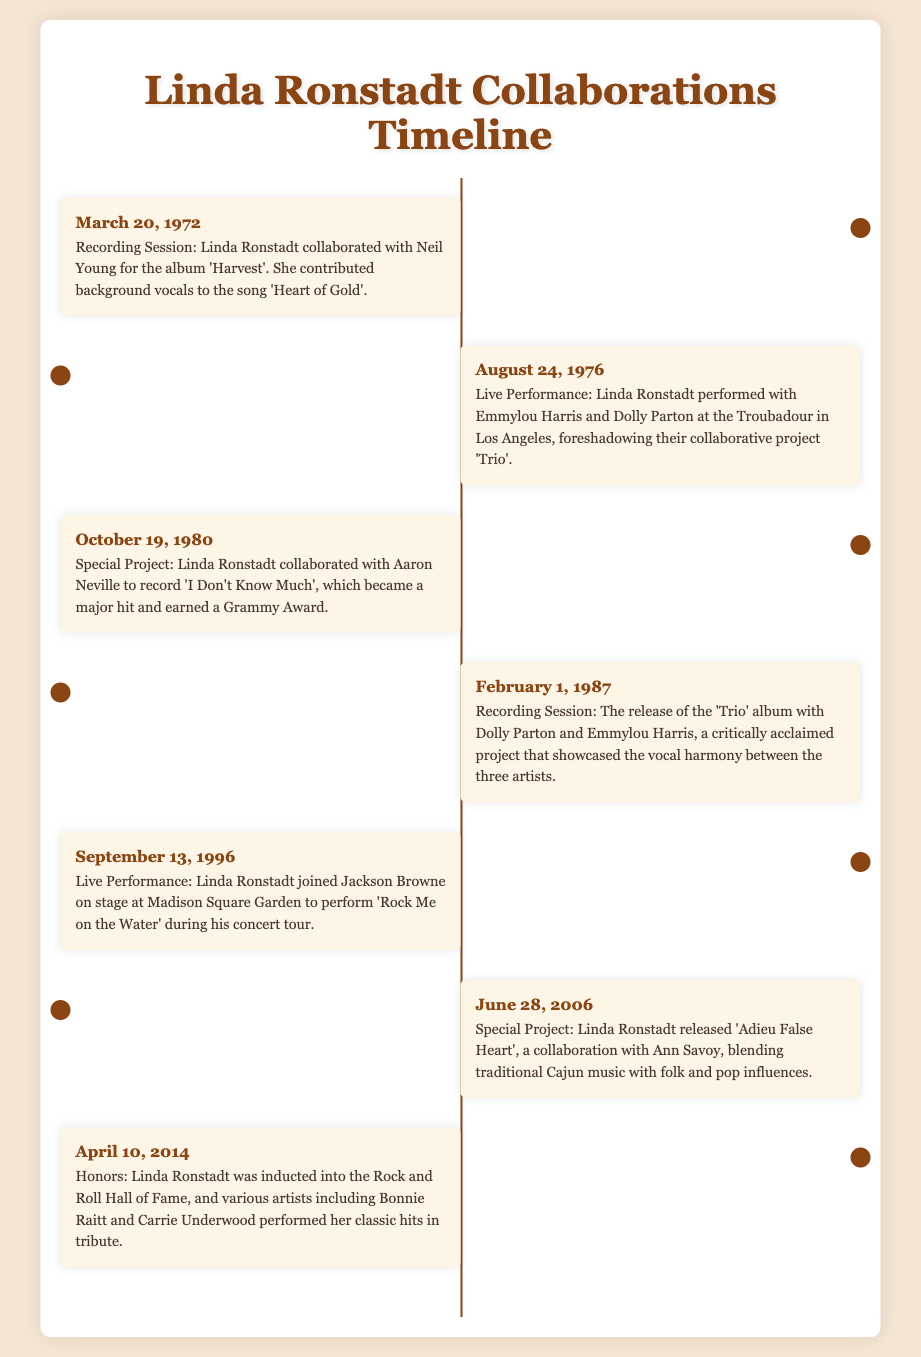What date did Linda Ronstadt collaborate with Neil Young? The document states that Linda Ronstadt collaborated with Neil Young on March 20, 1972.
Answer: March 20, 1972 What song did Linda Ronstadt provide background vocals for in 1972? According to the document, she contributed background vocals to the song 'Heart of Gold'.
Answer: Heart of Gold Who performed with Linda Ronstadt at the Troubadour in 1976? The document mentions that she performed with Emmylou Harris and Dolly Parton at that venue.
Answer: Emmylou Harris and Dolly Parton What was the title of Linda Ronstadt's collaboration with Aaron Neville? The document indicates that the song they recorded was titled 'I Don't Know Much'.
Answer: I Don't Know Much Which album was released on February 1, 1987? The document notes that the 'Trio' album was released on that date.
Answer: Trio How many artists collaborated on the 'Trio' album? The document mentions three artists collaborated on the 'Trio' album: Linda Ronstadt, Dolly Parton, and Emmylou Harris.
Answer: Three What significant event took place on April 10, 2014? The document states that Linda Ronstadt was inducted into the Rock and Roll Hall of Fame.
Answer: Induction into the Rock and Roll Hall of Fame Which artist performed a tribute during Linda Ronstadt's Hall of Fame induction? According to the document, Bonnie Raitt performed in tribute during the induction ceremony.
Answer: Bonnie Raitt What genre of music did Linda Ronstadt blend in 'Adieu False Heart'? The document describes her collaboration with Ann Savoy as blending traditional Cajun music with folk and pop influences.
Answer: Traditional Cajun music, folk, and pop influences 